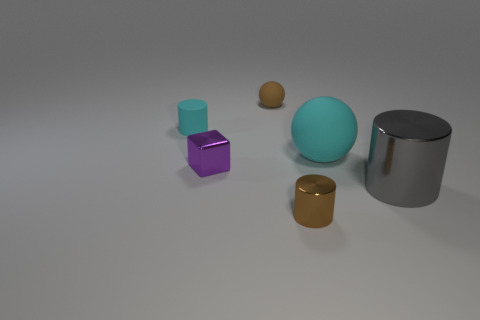Subtract all small brown metal cylinders. How many cylinders are left? 2 Subtract all gray cylinders. How many cylinders are left? 2 Subtract 2 cylinders. How many cylinders are left? 1 Add 2 brown metal objects. How many objects exist? 8 Add 2 large red matte blocks. How many large red matte blocks exist? 2 Subtract 0 green cubes. How many objects are left? 6 Subtract all spheres. How many objects are left? 4 Subtract all green balls. Subtract all yellow cylinders. How many balls are left? 2 Subtract all yellow cubes. How many brown spheres are left? 1 Subtract all purple metallic things. Subtract all tiny matte balls. How many objects are left? 4 